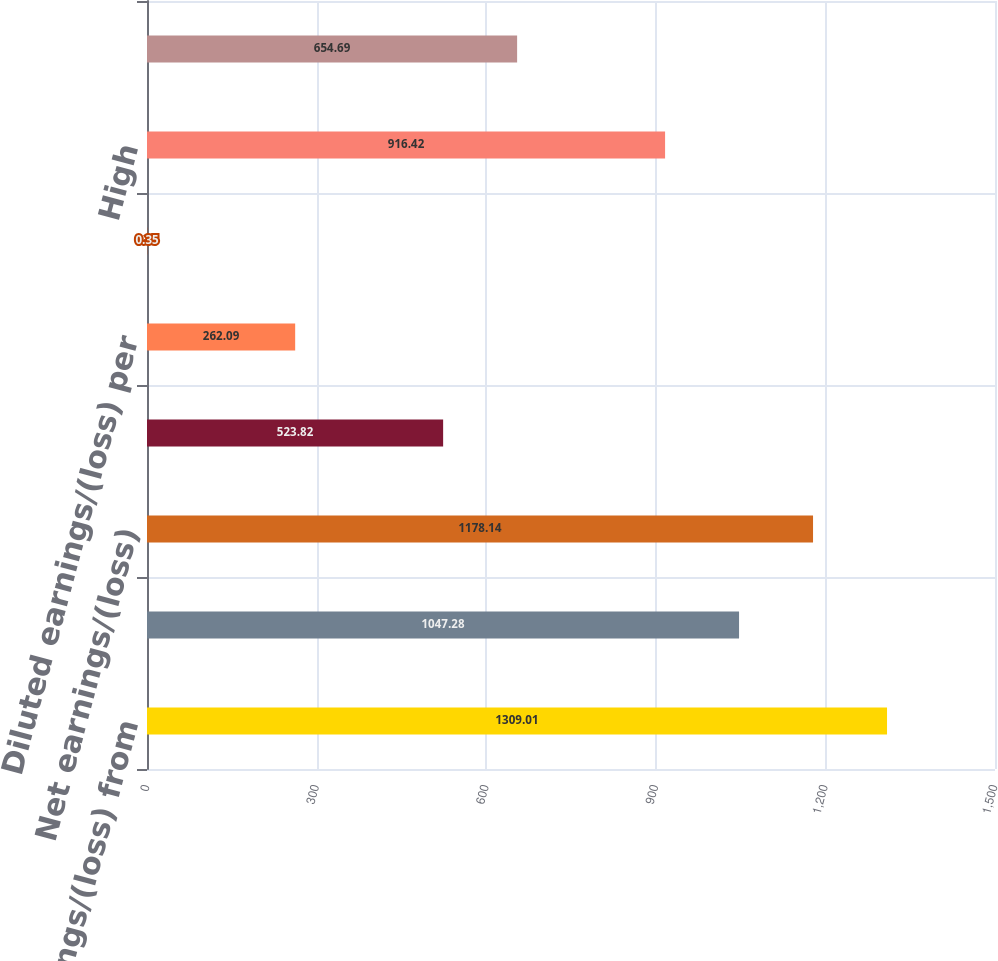Convert chart. <chart><loc_0><loc_0><loc_500><loc_500><bar_chart><fcel>Earnings/(loss) from<fcel>Net earnings/(loss) from<fcel>Net earnings/(loss)<fcel>Basic earnings/(loss) per<fcel>Diluted earnings/(loss) per<fcel>Cash dividends paid per share<fcel>High<fcel>Low<nl><fcel>1309.01<fcel>1047.28<fcel>1178.14<fcel>523.82<fcel>262.09<fcel>0.35<fcel>916.42<fcel>654.69<nl></chart> 